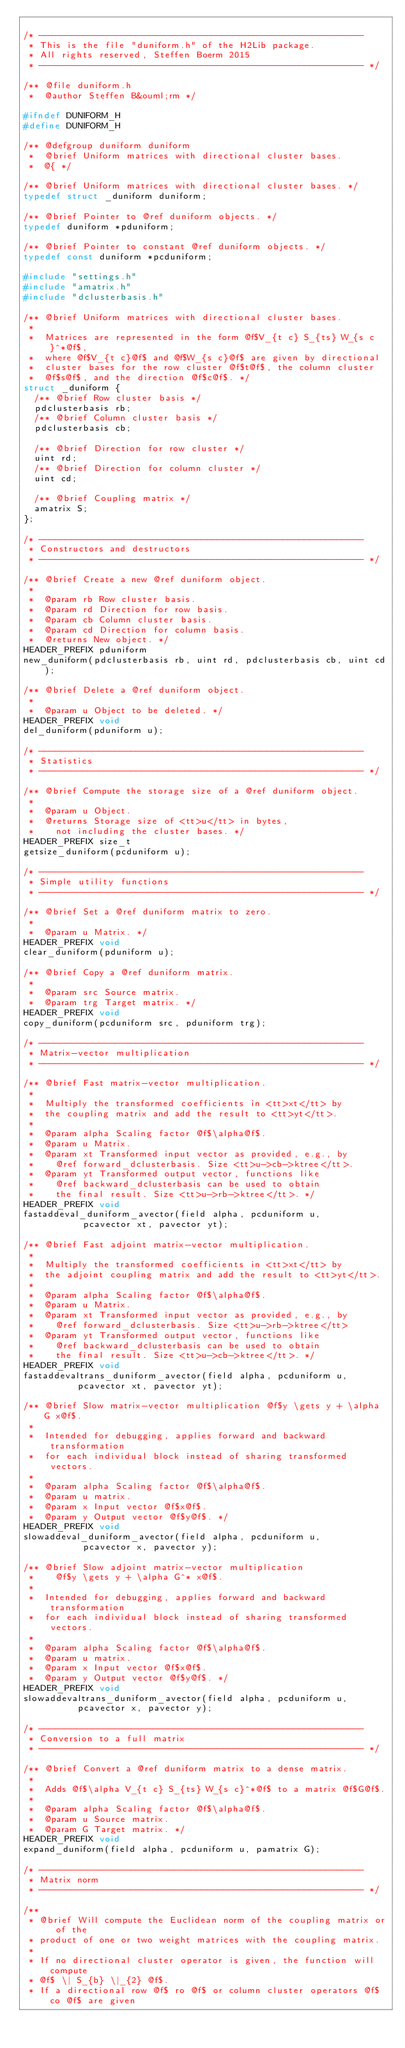Convert code to text. <code><loc_0><loc_0><loc_500><loc_500><_C_>
/* ------------------------------------------------------------
 * This is the file "duniform.h" of the H2Lib package.
 * All rights reserved, Steffen Boerm 2015
 * ------------------------------------------------------------ */

/** @file duniform.h
 *  @author Steffen B&ouml;rm */

#ifndef DUNIFORM_H
#define DUNIFORM_H

/** @defgroup duniform duniform
 *  @brief Uniform matrices with directional cluster bases.
 *  @{ */

/** @brief Uniform matrices with directional cluster bases. */
typedef struct _duniform duniform;

/** @brief Pointer to @ref duniform objects. */
typedef duniform *pduniform;

/** @brief Pointer to constant @ref duniform objects. */
typedef const duniform *pcduniform;

#include "settings.h"
#include "amatrix.h"
#include "dclusterbasis.h"

/** @brief Uniform matrices with directional cluster bases.
 *
 *  Matrices are represented in the form @f$V_{t c} S_{ts} W_{s c}^*@f$,
 *  where @f$V_{t c}@f$ and @f$W_{s c}@f$ are given by directional
 *  cluster bases for the row cluster @f$t@f$, the column cluster
 *  @f$s@f$, and the direction @f$c@f$. */
struct _duniform {
  /** @brief Row cluster basis */
  pdclusterbasis rb;
  /** @brief Column cluster basis */
  pdclusterbasis cb;

  /** @brief Direction for row cluster */
  uint rd;
  /** @brief Direction for column cluster */
  uint cd;

  /** @brief Coupling matrix */
  amatrix S;
};

/* ------------------------------------------------------------
 * Constructors and destructors
 * ------------------------------------------------------------ */

/** @brief Create a new @ref duniform object.
 *
 *  @param rb Row cluster basis.
 *  @param rd Direction for row basis.
 *  @param cb Column cluster basis.
 *  @param cd Direction for column basis.
 *  @returns New object. */
HEADER_PREFIX pduniform
new_duniform(pdclusterbasis rb, uint rd, pdclusterbasis cb, uint cd);

/** @brief Delete a @ref duniform object.
 *
 *  @param u Object to be deleted. */
HEADER_PREFIX void
del_duniform(pduniform u);

/* ------------------------------------------------------------
 * Statistics
 * ------------------------------------------------------------ */

/** @brief Compute the storage size of a @ref duniform object.
 *
 *  @param u Object.
 *  @returns Storage size of <tt>u</tt> in bytes,
 *    not including the cluster bases. */
HEADER_PREFIX size_t
getsize_duniform(pcduniform u);

/* ------------------------------------------------------------
 * Simple utility functions
 * ------------------------------------------------------------ */

/** @brief Set a @ref duniform matrix to zero.
 *
 *  @param u Matrix. */
HEADER_PREFIX void
clear_duniform(pduniform u);

/** @brief Copy a @ref duniform matrix.
 *
 *  @param src Source matrix.
 *  @param trg Target matrix. */
HEADER_PREFIX void
copy_duniform(pcduniform src, pduniform trg);

/* ------------------------------------------------------------
 * Matrix-vector multiplication
 * ------------------------------------------------------------ */

/** @brief Fast matrix-vector multiplication.
 *
 *  Multiply the transformed coefficients in <tt>xt</tt> by
 *  the coupling matrix and add the result to <tt>yt</tt>.
 *
 *  @param alpha Scaling factor @f$\alpha@f$.
 *  @param u Matrix.
 *  @param xt Transformed input vector as provided, e.g., by
 *    @ref forward_dclusterbasis. Size <tt>u->cb->ktree</tt>.
 *  @param yt Transformed output vector, functions like
 *    @ref backward_dclusterbasis can be used to obtain
 *    the final result. Size <tt>u->rb->ktree</tt>. */
HEADER_PREFIX void
fastaddeval_duniform_avector(field alpha, pcduniform u,
			     pcavector xt, pavector yt);

/** @brief Fast adjoint matrix-vector multiplication.
 *
 *  Multiply the transformed coefficients in <tt>xt</tt> by
 *  the adjoint coupling matrix and add the result to <tt>yt</tt>.
 *
 *  @param alpha Scaling factor @f$\alpha@f$.
 *  @param u Matrix.
 *  @param xt Transformed input vector as provided, e.g., by
 *    @ref forward_dclusterbasis. Size <tt>u->rb->ktree</tt>
 *  @param yt Transformed output vector, functions like
 *    @ref backward_dclusterbasis can be used to obtain
 *    the final result. Size <tt>u->cb->ktree</tt>. */
HEADER_PREFIX void
fastaddevaltrans_duniform_avector(field alpha, pcduniform u,
				  pcavector xt, pavector yt);

/** @brief Slow matrix-vector multiplication @f$y \gets y + \alpha G x@f$.
 *
 *  Intended for debugging, applies forward and backward transformation
 *  for each individual block instead of sharing transformed vectors.
 *
 *  @param alpha Scaling factor @f$\alpha@f$.
 *  @param u matrix.
 *  @param x Input vector @f$x@f$.
 *  @param y Output vector @f$y@f$. */
HEADER_PREFIX void
slowaddeval_duniform_avector(field alpha, pcduniform u,
			     pcavector x, pavector y);

/** @brief Slow adjoint matrix-vector multiplication
 *    @f$y \gets y + \alpha G^* x@f$.
 *
 *  Intended for debugging, applies forward and backward transformation
 *  for each individual block instead of sharing transformed vectors.
 *
 *  @param alpha Scaling factor @f$\alpha@f$.
 *  @param u matrix.
 *  @param x Input vector @f$x@f$.
 *  @param y Output vector @f$y@f$. */
HEADER_PREFIX void
slowaddevaltrans_duniform_avector(field alpha, pcduniform u,
				  pcavector x, pavector y);

/* ------------------------------------------------------------
 * Conversion to a full matrix
 * ------------------------------------------------------------ */

/** @brief Convert a @ref duniform matrix to a dense matrix.
 *
 *  Adds @f$\alpha V_{t c} S_{ts} W_{s c}^*@f$ to a matrix @f$G@f$.
 *
 *  @param alpha Scaling factor @f$\alpha@f$.
 *  @param u Source matrix.
 *  @param G Target matrix. */
HEADER_PREFIX void
expand_duniform(field alpha, pcduniform u, pamatrix G);

/* ------------------------------------------------------------
 * Matrix norm 
 * ------------------------------------------------------------ */

/**
 * @brief Will compute the Euclidean norm of the coupling matrix or of the
 * product of one or two weight matrices with the coupling matrix.
 * 
 * If no directional cluster operator is given, the function will compute
 * @f$ \| S_{b} \|_{2} @f$.
 * If a directional row @f$ ro @f$ or column cluster operators @f$ co @f$ are given</code> 